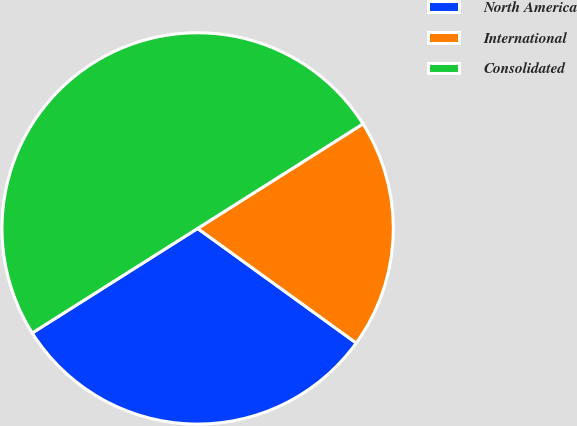Convert chart to OTSL. <chart><loc_0><loc_0><loc_500><loc_500><pie_chart><fcel>North America<fcel>International<fcel>Consolidated<nl><fcel>31.07%<fcel>18.93%<fcel>50.0%<nl></chart> 